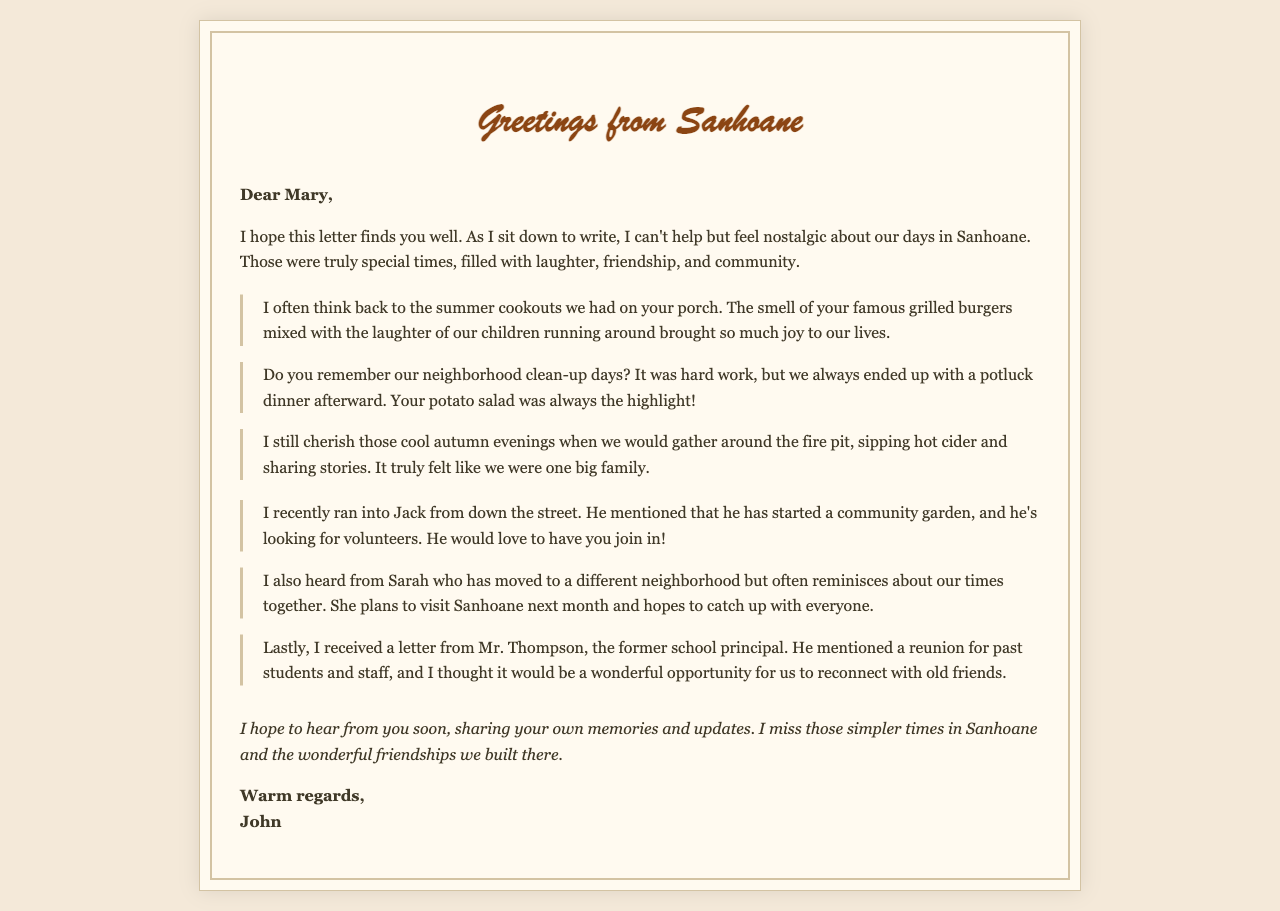what is the name of the sender? The sender's name is mentioned at the end of the letter, signed as "John."
Answer: John who is the recipient of the letter? The letter is addressed to Mary, as indicated in the greeting.
Answer: Mary what activity is Jack involved in? Jack is mentioned as starting a community garden, which he is looking for volunteers for.
Answer: community garden which dish was a highlight during the potluck dinners? The letter specifically mentions that Mary’s potato salad was the highlight of the potluck dinners.
Answer: potato salad what season is associated with the porch cookouts? The cookouts are described as taking place during the summer, as mentioned in the memory section.
Answer: summer what did the neighbors do after the clean-up days? After the neighborhood clean-up days, they would have a potluck dinner together.
Answer: potluck dinner who is planning to visit Sanhoane next month? Sarah, who has moved to a different neighborhood, plans to visit Sanhoane next month.
Answer: Sarah what event is Mr. Thompson mentioning in his letter? Mr. Thompson mentioned a reunion for past students and staff in his letter.
Answer: reunion how does the sender feel about the memories of Sanhoane? The sender expresses a feeling of nostalgia about the simpler times and wonderful friendships in Sanhoane.
Answer: nostalgia 